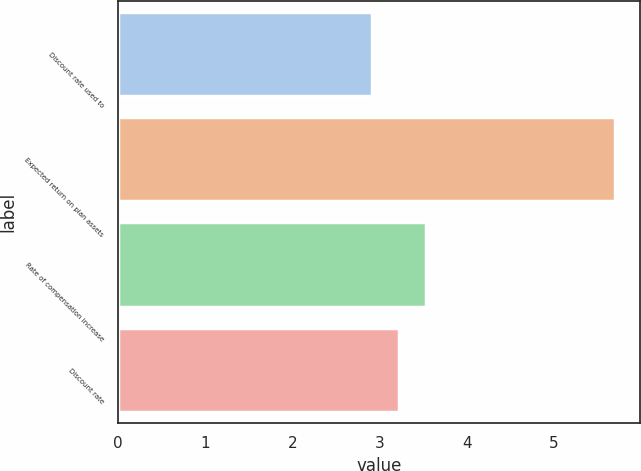<chart> <loc_0><loc_0><loc_500><loc_500><bar_chart><fcel>Discount rate used to<fcel>Expected return on plan assets<fcel>Rate of compensation increase<fcel>Discount rate<nl><fcel>2.91<fcel>5.7<fcel>3.53<fcel>3.22<nl></chart> 